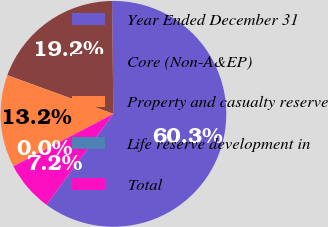Convert chart. <chart><loc_0><loc_0><loc_500><loc_500><pie_chart><fcel>Year Ended December 31<fcel>Core (Non-A&EP)<fcel>Property and casualty reserve<fcel>Life reserve development in<fcel>Total<nl><fcel>60.29%<fcel>19.25%<fcel>13.23%<fcel>0.03%<fcel>7.2%<nl></chart> 